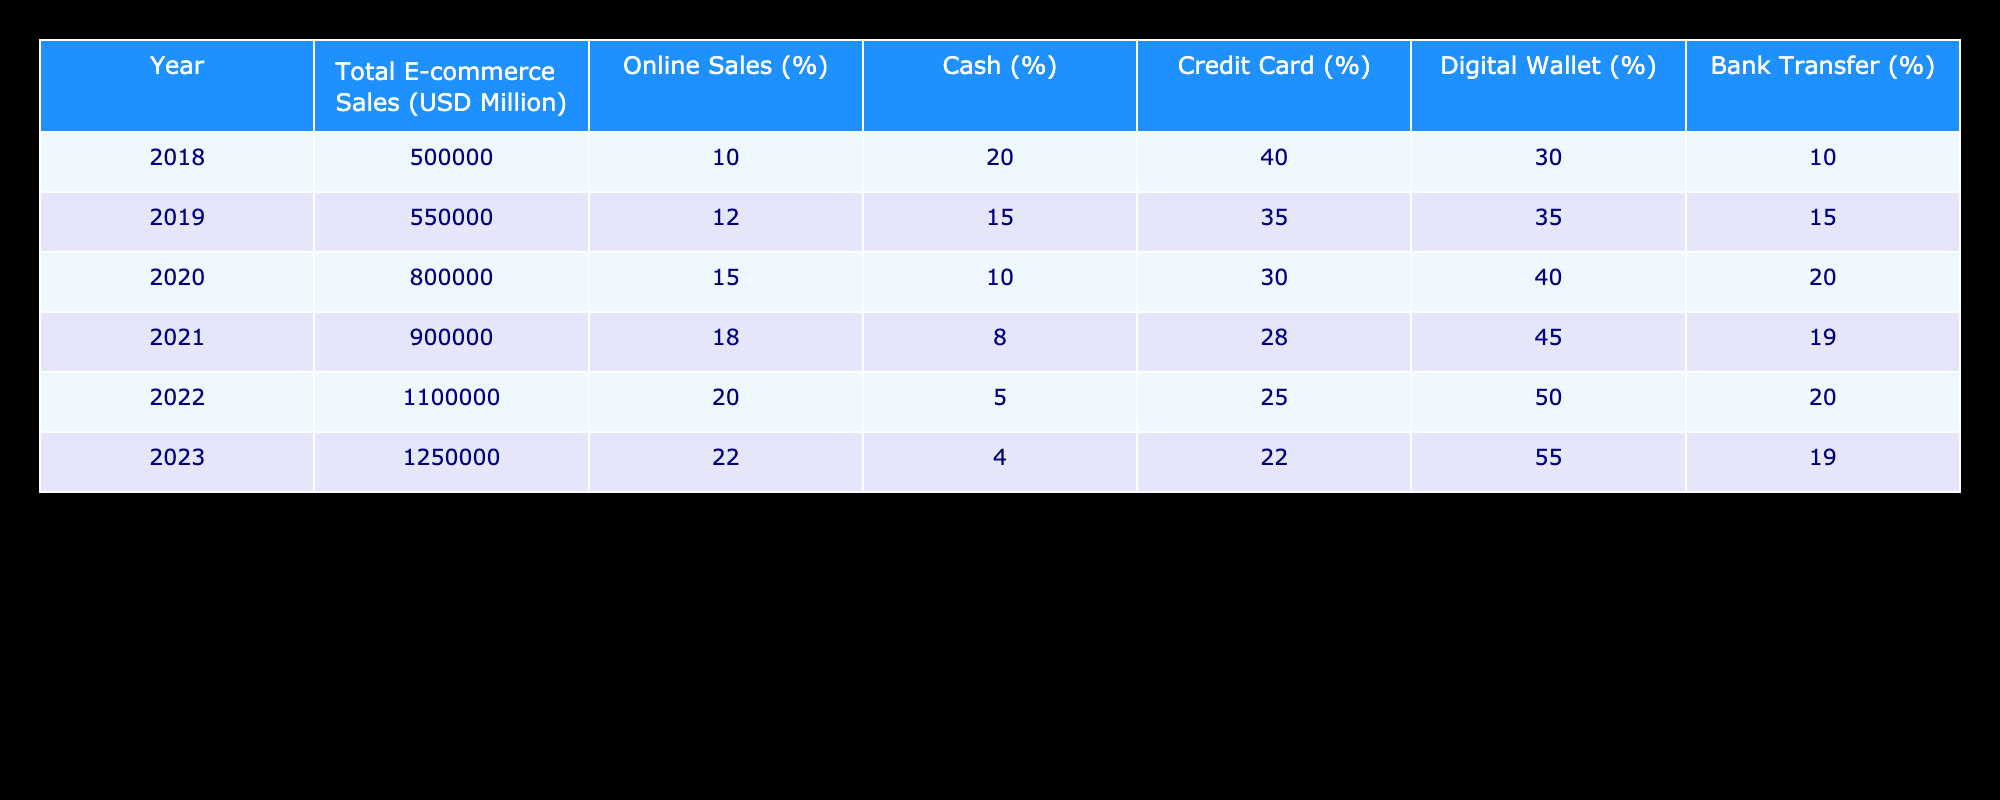What was the total e-commerce sales in 2020? The table shows that the total e-commerce sales for the year 2020 is listed as 800,000 million USD.
Answer: 800000 million USD In which year did the percentage of online sales exceed 15% for the first time? The percentages for online sales are 10.0% in 2018, 12.0% in 2019, and rise to 15.0% in 2020. Therefore, the first year with online sales exceeding 15% is 2020.
Answer: 2020 What is the difference in the percentage of cash payments from 2018 to 2023? The percentage of cash payments in 2018 is 20.0% and in 2023 it is 4.0%. The difference is 20.0% - 4.0% = 16.0%.
Answer: 16.0% Are digital wallet payments becoming more prevalent from 2018 to 2023? Yes, in 2018 digital wallet payments were at 30.0% and by 2023 they had increased to 55.0%. This indicates a rise in prevalence.
Answer: Yes What is the average percentage of bank transfer payments over all the years in the table? The bank transfer percentages over the years are: 10.0%, 15.0%, 20.0%, 19.0%, 20.0%, and 19.0%. Adding these gives 10.0 + 15.0 + 20.0 + 19.0 + 20.0 + 19.0 = 103.0%. Dividing by 6 gives an average of 17.17%.
Answer: 17.17% In which year was the percentage for credit card payments the lowest? Looking through the years, the percentage for credit card payments was 40.0% in 2018, 35.0% in 2019, 30.0% in 2020, 28.0% in 2021, 25.0% in 2022, and 22.0% in 2023. The lowest percentage is 22.0% in 2023.
Answer: 2023 How much did total e-commerce sales increase from 2021 to 2022? The total e-commerce sales were 900,000 million USD in 2021 and 1,100,000 million USD in 2022. The increase is 1,100,000 - 900,000 = 200,000 million USD.
Answer: 200000 million USD Is the percentage of online sales consistently increasing every year? Yes, the percentage of online sales is reported as 10.0%, 12.0%, 15.0%, 18.0%, 20.0%, and 22.0%, which shows a consistent increase each year.
Answer: Yes What was the total e-commerce sales for the year with the highest percentage of digital wallet payments? The year with the highest percentage of digital wallet payments is 2023, with 55.0%, and the total e-commerce sales that year were 1,250,000 million USD.
Answer: 1250000 million USD 